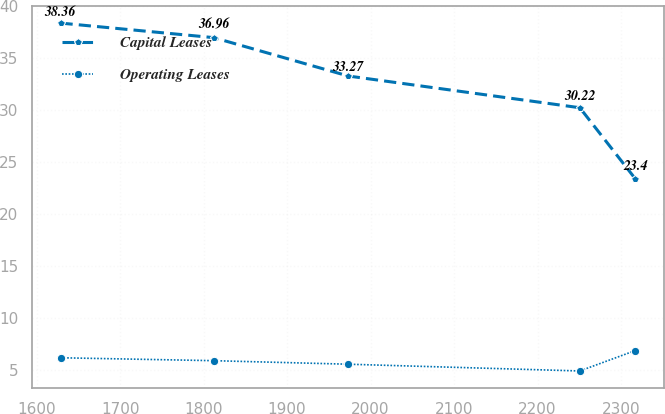Convert chart to OTSL. <chart><loc_0><loc_0><loc_500><loc_500><line_chart><ecel><fcel>Capital Leases<fcel>Operating Leases<nl><fcel>1628.63<fcel>38.36<fcel>6.18<nl><fcel>1812.19<fcel>36.96<fcel>5.9<nl><fcel>1973.29<fcel>33.27<fcel>5.56<nl><fcel>2250.65<fcel>30.22<fcel>4.91<nl><fcel>2317.04<fcel>23.4<fcel>6.87<nl></chart> 